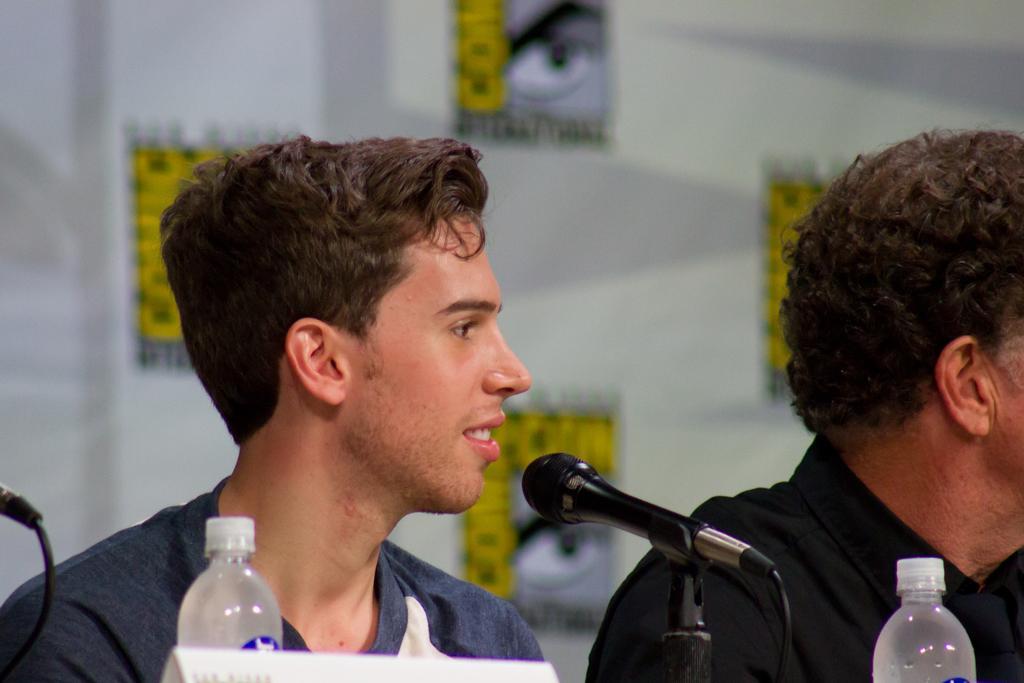How would you summarize this image in a sentence or two? In this picture we can see two persons were on left person in front of mic and smiling and in front of them we can see two bottles, wire and in background we can see wall with some posters. 